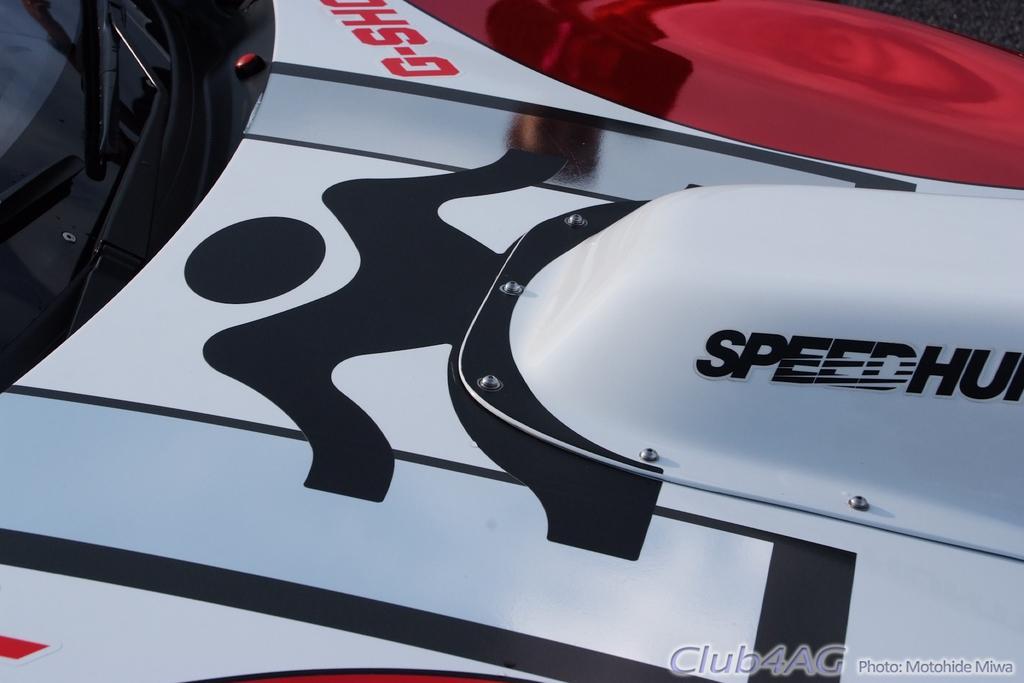Could you give a brief overview of what you see in this image? In this image I can see a vehicle which is in white,black and red color. In front I can see a glass and something is written on it. 